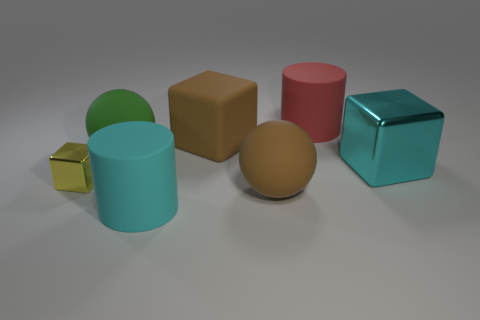Does the cylinder in front of the tiny metallic cube have the same color as the large metal block?
Provide a short and direct response. Yes. How many shiny things are tiny yellow cubes or large green spheres?
Give a very brief answer. 1. The big cyan rubber object is what shape?
Your response must be concise. Cylinder. Is the material of the green thing the same as the yellow block?
Your response must be concise. No. Is there a matte object left of the large matte ball on the right side of the cube that is behind the green thing?
Provide a succinct answer. Yes. What number of other things are there of the same shape as the red rubber thing?
Your answer should be compact. 1. There is a thing that is in front of the yellow metal block and on the left side of the large brown matte ball; what is its shape?
Give a very brief answer. Cylinder. There is a cylinder that is behind the cylinder in front of the big rubber cylinder behind the large cyan cylinder; what color is it?
Your answer should be very brief. Red. Is the number of red objects on the right side of the cyan cube greater than the number of large cubes that are on the left side of the cyan matte thing?
Ensure brevity in your answer.  No. What number of other objects are the same size as the cyan metal object?
Give a very brief answer. 5. 